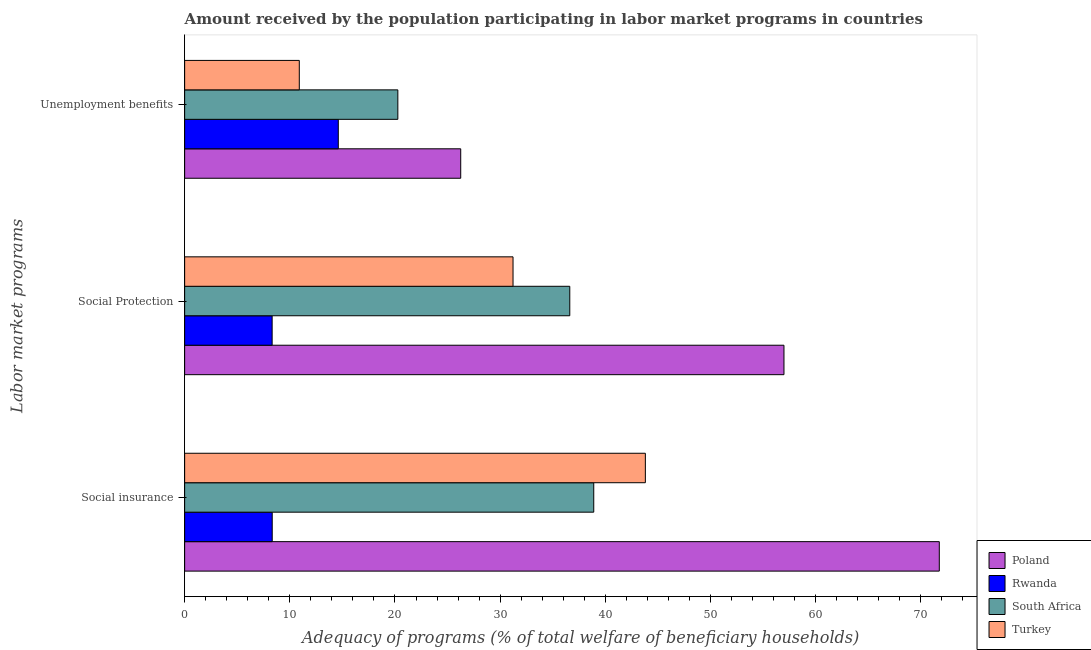How many groups of bars are there?
Ensure brevity in your answer.  3. Are the number of bars on each tick of the Y-axis equal?
Offer a terse response. Yes. What is the label of the 1st group of bars from the top?
Offer a terse response. Unemployment benefits. What is the amount received by the population participating in social protection programs in Turkey?
Provide a short and direct response. 31.22. Across all countries, what is the maximum amount received by the population participating in social protection programs?
Provide a succinct answer. 56.99. Across all countries, what is the minimum amount received by the population participating in social insurance programs?
Provide a short and direct response. 8.33. In which country was the amount received by the population participating in unemployment benefits programs minimum?
Your answer should be compact. Turkey. What is the total amount received by the population participating in unemployment benefits programs in the graph?
Make the answer very short. 72.04. What is the difference between the amount received by the population participating in social protection programs in South Africa and that in Rwanda?
Give a very brief answer. 28.3. What is the difference between the amount received by the population participating in social protection programs in Rwanda and the amount received by the population participating in unemployment benefits programs in Turkey?
Give a very brief answer. -2.58. What is the average amount received by the population participating in social insurance programs per country?
Your response must be concise. 40.7. What is the difference between the amount received by the population participating in unemployment benefits programs and amount received by the population participating in social protection programs in Turkey?
Keep it short and to the point. -20.32. What is the ratio of the amount received by the population participating in unemployment benefits programs in Rwanda to that in Turkey?
Provide a short and direct response. 1.34. Is the amount received by the population participating in unemployment benefits programs in Rwanda less than that in Turkey?
Provide a succinct answer. No. What is the difference between the highest and the second highest amount received by the population participating in social insurance programs?
Keep it short and to the point. 27.95. What is the difference between the highest and the lowest amount received by the population participating in social insurance programs?
Provide a succinct answer. 63.43. Is the sum of the amount received by the population participating in social insurance programs in Rwanda and Poland greater than the maximum amount received by the population participating in social protection programs across all countries?
Provide a succinct answer. Yes. What does the 4th bar from the bottom in Social Protection represents?
Your answer should be compact. Turkey. Are all the bars in the graph horizontal?
Provide a short and direct response. Yes. How many countries are there in the graph?
Your response must be concise. 4. What is the difference between two consecutive major ticks on the X-axis?
Provide a short and direct response. 10. Does the graph contain grids?
Provide a succinct answer. No. Where does the legend appear in the graph?
Provide a succinct answer. Bottom right. How many legend labels are there?
Ensure brevity in your answer.  4. How are the legend labels stacked?
Offer a very short reply. Vertical. What is the title of the graph?
Keep it short and to the point. Amount received by the population participating in labor market programs in countries. What is the label or title of the X-axis?
Offer a terse response. Adequacy of programs (% of total welfare of beneficiary households). What is the label or title of the Y-axis?
Ensure brevity in your answer.  Labor market programs. What is the Adequacy of programs (% of total welfare of beneficiary households) of Poland in Social insurance?
Your answer should be compact. 71.75. What is the Adequacy of programs (% of total welfare of beneficiary households) of Rwanda in Social insurance?
Provide a short and direct response. 8.33. What is the Adequacy of programs (% of total welfare of beneficiary households) in South Africa in Social insurance?
Offer a terse response. 38.9. What is the Adequacy of programs (% of total welfare of beneficiary households) of Turkey in Social insurance?
Offer a very short reply. 43.81. What is the Adequacy of programs (% of total welfare of beneficiary households) of Poland in Social Protection?
Give a very brief answer. 56.99. What is the Adequacy of programs (% of total welfare of beneficiary households) of Rwanda in Social Protection?
Your answer should be compact. 8.32. What is the Adequacy of programs (% of total welfare of beneficiary households) in South Africa in Social Protection?
Give a very brief answer. 36.62. What is the Adequacy of programs (% of total welfare of beneficiary households) of Turkey in Social Protection?
Your answer should be very brief. 31.22. What is the Adequacy of programs (% of total welfare of beneficiary households) in Poland in Unemployment benefits?
Your response must be concise. 26.25. What is the Adequacy of programs (% of total welfare of beneficiary households) in Rwanda in Unemployment benefits?
Provide a short and direct response. 14.61. What is the Adequacy of programs (% of total welfare of beneficiary households) in South Africa in Unemployment benefits?
Provide a short and direct response. 20.27. What is the Adequacy of programs (% of total welfare of beneficiary households) of Turkey in Unemployment benefits?
Offer a terse response. 10.9. Across all Labor market programs, what is the maximum Adequacy of programs (% of total welfare of beneficiary households) of Poland?
Offer a terse response. 71.75. Across all Labor market programs, what is the maximum Adequacy of programs (% of total welfare of beneficiary households) of Rwanda?
Your answer should be compact. 14.61. Across all Labor market programs, what is the maximum Adequacy of programs (% of total welfare of beneficiary households) in South Africa?
Provide a short and direct response. 38.9. Across all Labor market programs, what is the maximum Adequacy of programs (% of total welfare of beneficiary households) of Turkey?
Your answer should be very brief. 43.81. Across all Labor market programs, what is the minimum Adequacy of programs (% of total welfare of beneficiary households) of Poland?
Ensure brevity in your answer.  26.25. Across all Labor market programs, what is the minimum Adequacy of programs (% of total welfare of beneficiary households) of Rwanda?
Provide a succinct answer. 8.32. Across all Labor market programs, what is the minimum Adequacy of programs (% of total welfare of beneficiary households) in South Africa?
Your response must be concise. 20.27. Across all Labor market programs, what is the minimum Adequacy of programs (% of total welfare of beneficiary households) in Turkey?
Offer a very short reply. 10.9. What is the total Adequacy of programs (% of total welfare of beneficiary households) of Poland in the graph?
Make the answer very short. 154.99. What is the total Adequacy of programs (% of total welfare of beneficiary households) of Rwanda in the graph?
Keep it short and to the point. 31.26. What is the total Adequacy of programs (% of total welfare of beneficiary households) of South Africa in the graph?
Keep it short and to the point. 95.79. What is the total Adequacy of programs (% of total welfare of beneficiary households) in Turkey in the graph?
Give a very brief answer. 85.93. What is the difference between the Adequacy of programs (% of total welfare of beneficiary households) in Poland in Social insurance and that in Social Protection?
Your answer should be compact. 14.77. What is the difference between the Adequacy of programs (% of total welfare of beneficiary households) of Rwanda in Social insurance and that in Social Protection?
Offer a very short reply. 0.01. What is the difference between the Adequacy of programs (% of total welfare of beneficiary households) of South Africa in Social insurance and that in Social Protection?
Your answer should be very brief. 2.28. What is the difference between the Adequacy of programs (% of total welfare of beneficiary households) of Turkey in Social insurance and that in Social Protection?
Provide a short and direct response. 12.58. What is the difference between the Adequacy of programs (% of total welfare of beneficiary households) in Poland in Social insurance and that in Unemployment benefits?
Make the answer very short. 45.5. What is the difference between the Adequacy of programs (% of total welfare of beneficiary households) of Rwanda in Social insurance and that in Unemployment benefits?
Your answer should be compact. -6.28. What is the difference between the Adequacy of programs (% of total welfare of beneficiary households) of South Africa in Social insurance and that in Unemployment benefits?
Your response must be concise. 18.63. What is the difference between the Adequacy of programs (% of total welfare of beneficiary households) of Turkey in Social insurance and that in Unemployment benefits?
Keep it short and to the point. 32.9. What is the difference between the Adequacy of programs (% of total welfare of beneficiary households) of Poland in Social Protection and that in Unemployment benefits?
Ensure brevity in your answer.  30.74. What is the difference between the Adequacy of programs (% of total welfare of beneficiary households) of Rwanda in Social Protection and that in Unemployment benefits?
Offer a very short reply. -6.29. What is the difference between the Adequacy of programs (% of total welfare of beneficiary households) in South Africa in Social Protection and that in Unemployment benefits?
Ensure brevity in your answer.  16.35. What is the difference between the Adequacy of programs (% of total welfare of beneficiary households) in Turkey in Social Protection and that in Unemployment benefits?
Your answer should be compact. 20.32. What is the difference between the Adequacy of programs (% of total welfare of beneficiary households) in Poland in Social insurance and the Adequacy of programs (% of total welfare of beneficiary households) in Rwanda in Social Protection?
Provide a short and direct response. 63.43. What is the difference between the Adequacy of programs (% of total welfare of beneficiary households) in Poland in Social insurance and the Adequacy of programs (% of total welfare of beneficiary households) in South Africa in Social Protection?
Give a very brief answer. 35.13. What is the difference between the Adequacy of programs (% of total welfare of beneficiary households) of Poland in Social insurance and the Adequacy of programs (% of total welfare of beneficiary households) of Turkey in Social Protection?
Make the answer very short. 40.53. What is the difference between the Adequacy of programs (% of total welfare of beneficiary households) in Rwanda in Social insurance and the Adequacy of programs (% of total welfare of beneficiary households) in South Africa in Social Protection?
Your answer should be compact. -28.29. What is the difference between the Adequacy of programs (% of total welfare of beneficiary households) of Rwanda in Social insurance and the Adequacy of programs (% of total welfare of beneficiary households) of Turkey in Social Protection?
Offer a very short reply. -22.9. What is the difference between the Adequacy of programs (% of total welfare of beneficiary households) in South Africa in Social insurance and the Adequacy of programs (% of total welfare of beneficiary households) in Turkey in Social Protection?
Keep it short and to the point. 7.68. What is the difference between the Adequacy of programs (% of total welfare of beneficiary households) in Poland in Social insurance and the Adequacy of programs (% of total welfare of beneficiary households) in Rwanda in Unemployment benefits?
Offer a terse response. 57.14. What is the difference between the Adequacy of programs (% of total welfare of beneficiary households) of Poland in Social insurance and the Adequacy of programs (% of total welfare of beneficiary households) of South Africa in Unemployment benefits?
Ensure brevity in your answer.  51.48. What is the difference between the Adequacy of programs (% of total welfare of beneficiary households) of Poland in Social insurance and the Adequacy of programs (% of total welfare of beneficiary households) of Turkey in Unemployment benefits?
Your answer should be compact. 60.85. What is the difference between the Adequacy of programs (% of total welfare of beneficiary households) in Rwanda in Social insurance and the Adequacy of programs (% of total welfare of beneficiary households) in South Africa in Unemployment benefits?
Your answer should be compact. -11.94. What is the difference between the Adequacy of programs (% of total welfare of beneficiary households) in Rwanda in Social insurance and the Adequacy of programs (% of total welfare of beneficiary households) in Turkey in Unemployment benefits?
Provide a short and direct response. -2.58. What is the difference between the Adequacy of programs (% of total welfare of beneficiary households) of South Africa in Social insurance and the Adequacy of programs (% of total welfare of beneficiary households) of Turkey in Unemployment benefits?
Your answer should be very brief. 28. What is the difference between the Adequacy of programs (% of total welfare of beneficiary households) of Poland in Social Protection and the Adequacy of programs (% of total welfare of beneficiary households) of Rwanda in Unemployment benefits?
Keep it short and to the point. 42.38. What is the difference between the Adequacy of programs (% of total welfare of beneficiary households) in Poland in Social Protection and the Adequacy of programs (% of total welfare of beneficiary households) in South Africa in Unemployment benefits?
Provide a succinct answer. 36.71. What is the difference between the Adequacy of programs (% of total welfare of beneficiary households) in Poland in Social Protection and the Adequacy of programs (% of total welfare of beneficiary households) in Turkey in Unemployment benefits?
Provide a short and direct response. 46.08. What is the difference between the Adequacy of programs (% of total welfare of beneficiary households) of Rwanda in Social Protection and the Adequacy of programs (% of total welfare of beneficiary households) of South Africa in Unemployment benefits?
Keep it short and to the point. -11.95. What is the difference between the Adequacy of programs (% of total welfare of beneficiary households) of Rwanda in Social Protection and the Adequacy of programs (% of total welfare of beneficiary households) of Turkey in Unemployment benefits?
Your response must be concise. -2.58. What is the difference between the Adequacy of programs (% of total welfare of beneficiary households) of South Africa in Social Protection and the Adequacy of programs (% of total welfare of beneficiary households) of Turkey in Unemployment benefits?
Provide a short and direct response. 25.72. What is the average Adequacy of programs (% of total welfare of beneficiary households) of Poland per Labor market programs?
Give a very brief answer. 51.66. What is the average Adequacy of programs (% of total welfare of beneficiary households) in Rwanda per Labor market programs?
Offer a terse response. 10.42. What is the average Adequacy of programs (% of total welfare of beneficiary households) in South Africa per Labor market programs?
Your answer should be very brief. 31.93. What is the average Adequacy of programs (% of total welfare of beneficiary households) of Turkey per Labor market programs?
Offer a very short reply. 28.64. What is the difference between the Adequacy of programs (% of total welfare of beneficiary households) in Poland and Adequacy of programs (% of total welfare of beneficiary households) in Rwanda in Social insurance?
Ensure brevity in your answer.  63.43. What is the difference between the Adequacy of programs (% of total welfare of beneficiary households) in Poland and Adequacy of programs (% of total welfare of beneficiary households) in South Africa in Social insurance?
Provide a short and direct response. 32.85. What is the difference between the Adequacy of programs (% of total welfare of beneficiary households) of Poland and Adequacy of programs (% of total welfare of beneficiary households) of Turkey in Social insurance?
Give a very brief answer. 27.95. What is the difference between the Adequacy of programs (% of total welfare of beneficiary households) in Rwanda and Adequacy of programs (% of total welfare of beneficiary households) in South Africa in Social insurance?
Your answer should be compact. -30.57. What is the difference between the Adequacy of programs (% of total welfare of beneficiary households) in Rwanda and Adequacy of programs (% of total welfare of beneficiary households) in Turkey in Social insurance?
Ensure brevity in your answer.  -35.48. What is the difference between the Adequacy of programs (% of total welfare of beneficiary households) in South Africa and Adequacy of programs (% of total welfare of beneficiary households) in Turkey in Social insurance?
Provide a short and direct response. -4.91. What is the difference between the Adequacy of programs (% of total welfare of beneficiary households) of Poland and Adequacy of programs (% of total welfare of beneficiary households) of Rwanda in Social Protection?
Ensure brevity in your answer.  48.67. What is the difference between the Adequacy of programs (% of total welfare of beneficiary households) of Poland and Adequacy of programs (% of total welfare of beneficiary households) of South Africa in Social Protection?
Your answer should be very brief. 20.36. What is the difference between the Adequacy of programs (% of total welfare of beneficiary households) in Poland and Adequacy of programs (% of total welfare of beneficiary households) in Turkey in Social Protection?
Provide a succinct answer. 25.76. What is the difference between the Adequacy of programs (% of total welfare of beneficiary households) in Rwanda and Adequacy of programs (% of total welfare of beneficiary households) in South Africa in Social Protection?
Keep it short and to the point. -28.3. What is the difference between the Adequacy of programs (% of total welfare of beneficiary households) in Rwanda and Adequacy of programs (% of total welfare of beneficiary households) in Turkey in Social Protection?
Provide a succinct answer. -22.9. What is the difference between the Adequacy of programs (% of total welfare of beneficiary households) in South Africa and Adequacy of programs (% of total welfare of beneficiary households) in Turkey in Social Protection?
Ensure brevity in your answer.  5.4. What is the difference between the Adequacy of programs (% of total welfare of beneficiary households) in Poland and Adequacy of programs (% of total welfare of beneficiary households) in Rwanda in Unemployment benefits?
Your answer should be compact. 11.64. What is the difference between the Adequacy of programs (% of total welfare of beneficiary households) in Poland and Adequacy of programs (% of total welfare of beneficiary households) in South Africa in Unemployment benefits?
Offer a terse response. 5.98. What is the difference between the Adequacy of programs (% of total welfare of beneficiary households) of Poland and Adequacy of programs (% of total welfare of beneficiary households) of Turkey in Unemployment benefits?
Provide a succinct answer. 15.35. What is the difference between the Adequacy of programs (% of total welfare of beneficiary households) in Rwanda and Adequacy of programs (% of total welfare of beneficiary households) in South Africa in Unemployment benefits?
Your answer should be very brief. -5.66. What is the difference between the Adequacy of programs (% of total welfare of beneficiary households) of Rwanda and Adequacy of programs (% of total welfare of beneficiary households) of Turkey in Unemployment benefits?
Your answer should be very brief. 3.71. What is the difference between the Adequacy of programs (% of total welfare of beneficiary households) in South Africa and Adequacy of programs (% of total welfare of beneficiary households) in Turkey in Unemployment benefits?
Provide a succinct answer. 9.37. What is the ratio of the Adequacy of programs (% of total welfare of beneficiary households) of Poland in Social insurance to that in Social Protection?
Your answer should be very brief. 1.26. What is the ratio of the Adequacy of programs (% of total welfare of beneficiary households) in Rwanda in Social insurance to that in Social Protection?
Give a very brief answer. 1. What is the ratio of the Adequacy of programs (% of total welfare of beneficiary households) in South Africa in Social insurance to that in Social Protection?
Keep it short and to the point. 1.06. What is the ratio of the Adequacy of programs (% of total welfare of beneficiary households) of Turkey in Social insurance to that in Social Protection?
Make the answer very short. 1.4. What is the ratio of the Adequacy of programs (% of total welfare of beneficiary households) of Poland in Social insurance to that in Unemployment benefits?
Your answer should be compact. 2.73. What is the ratio of the Adequacy of programs (% of total welfare of beneficiary households) of Rwanda in Social insurance to that in Unemployment benefits?
Provide a short and direct response. 0.57. What is the ratio of the Adequacy of programs (% of total welfare of beneficiary households) of South Africa in Social insurance to that in Unemployment benefits?
Your answer should be compact. 1.92. What is the ratio of the Adequacy of programs (% of total welfare of beneficiary households) in Turkey in Social insurance to that in Unemployment benefits?
Make the answer very short. 4.02. What is the ratio of the Adequacy of programs (% of total welfare of beneficiary households) of Poland in Social Protection to that in Unemployment benefits?
Ensure brevity in your answer.  2.17. What is the ratio of the Adequacy of programs (% of total welfare of beneficiary households) in Rwanda in Social Protection to that in Unemployment benefits?
Your answer should be very brief. 0.57. What is the ratio of the Adequacy of programs (% of total welfare of beneficiary households) of South Africa in Social Protection to that in Unemployment benefits?
Provide a short and direct response. 1.81. What is the ratio of the Adequacy of programs (% of total welfare of beneficiary households) in Turkey in Social Protection to that in Unemployment benefits?
Provide a succinct answer. 2.86. What is the difference between the highest and the second highest Adequacy of programs (% of total welfare of beneficiary households) of Poland?
Ensure brevity in your answer.  14.77. What is the difference between the highest and the second highest Adequacy of programs (% of total welfare of beneficiary households) of Rwanda?
Your response must be concise. 6.28. What is the difference between the highest and the second highest Adequacy of programs (% of total welfare of beneficiary households) in South Africa?
Your answer should be very brief. 2.28. What is the difference between the highest and the second highest Adequacy of programs (% of total welfare of beneficiary households) in Turkey?
Give a very brief answer. 12.58. What is the difference between the highest and the lowest Adequacy of programs (% of total welfare of beneficiary households) in Poland?
Ensure brevity in your answer.  45.5. What is the difference between the highest and the lowest Adequacy of programs (% of total welfare of beneficiary households) of Rwanda?
Ensure brevity in your answer.  6.29. What is the difference between the highest and the lowest Adequacy of programs (% of total welfare of beneficiary households) in South Africa?
Offer a very short reply. 18.63. What is the difference between the highest and the lowest Adequacy of programs (% of total welfare of beneficiary households) of Turkey?
Your answer should be compact. 32.9. 